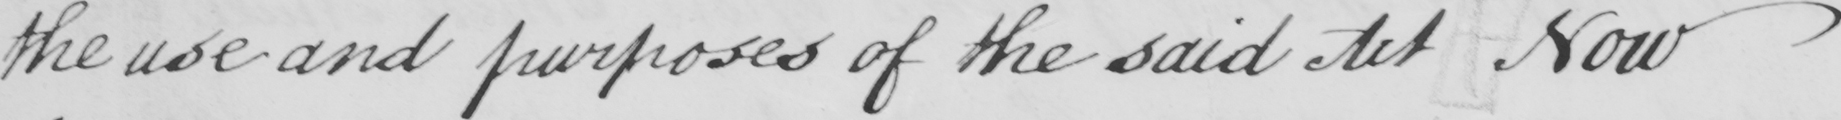Can you tell me what this handwritten text says? the use and purposes of the said Act Now 